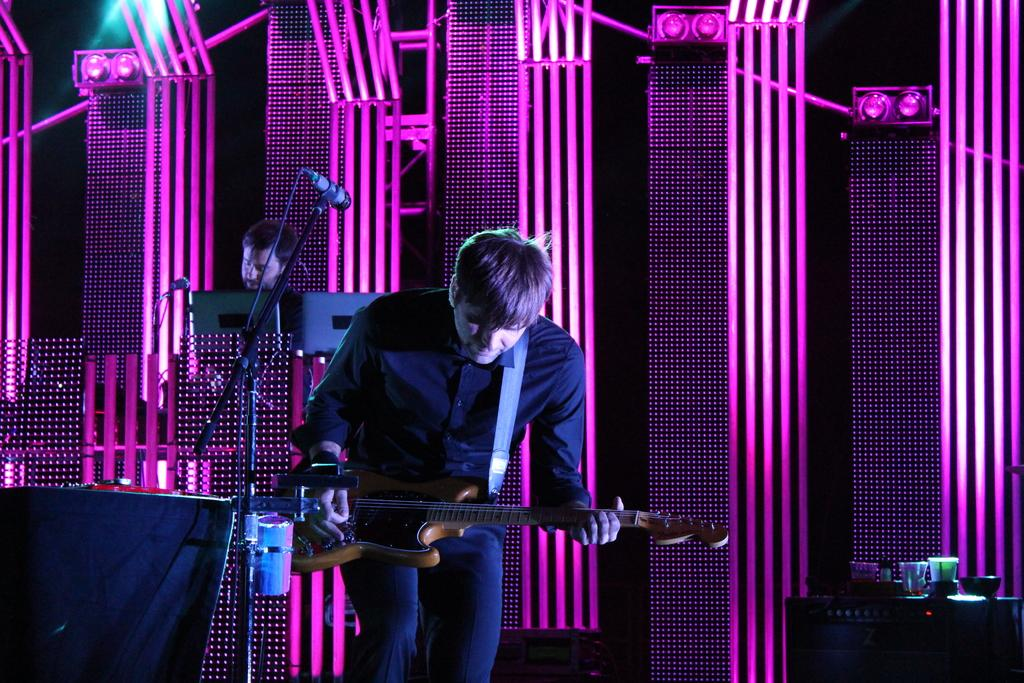What is the man in the image doing? The man is playing a guitar in the image. What object is visible in the image that is related to lighting? There is a disco light visible in the image. How many boats can be seen in the image? There are no boats present in the image. What type of destruction is visible in the image? There is no destruction present in the image. 